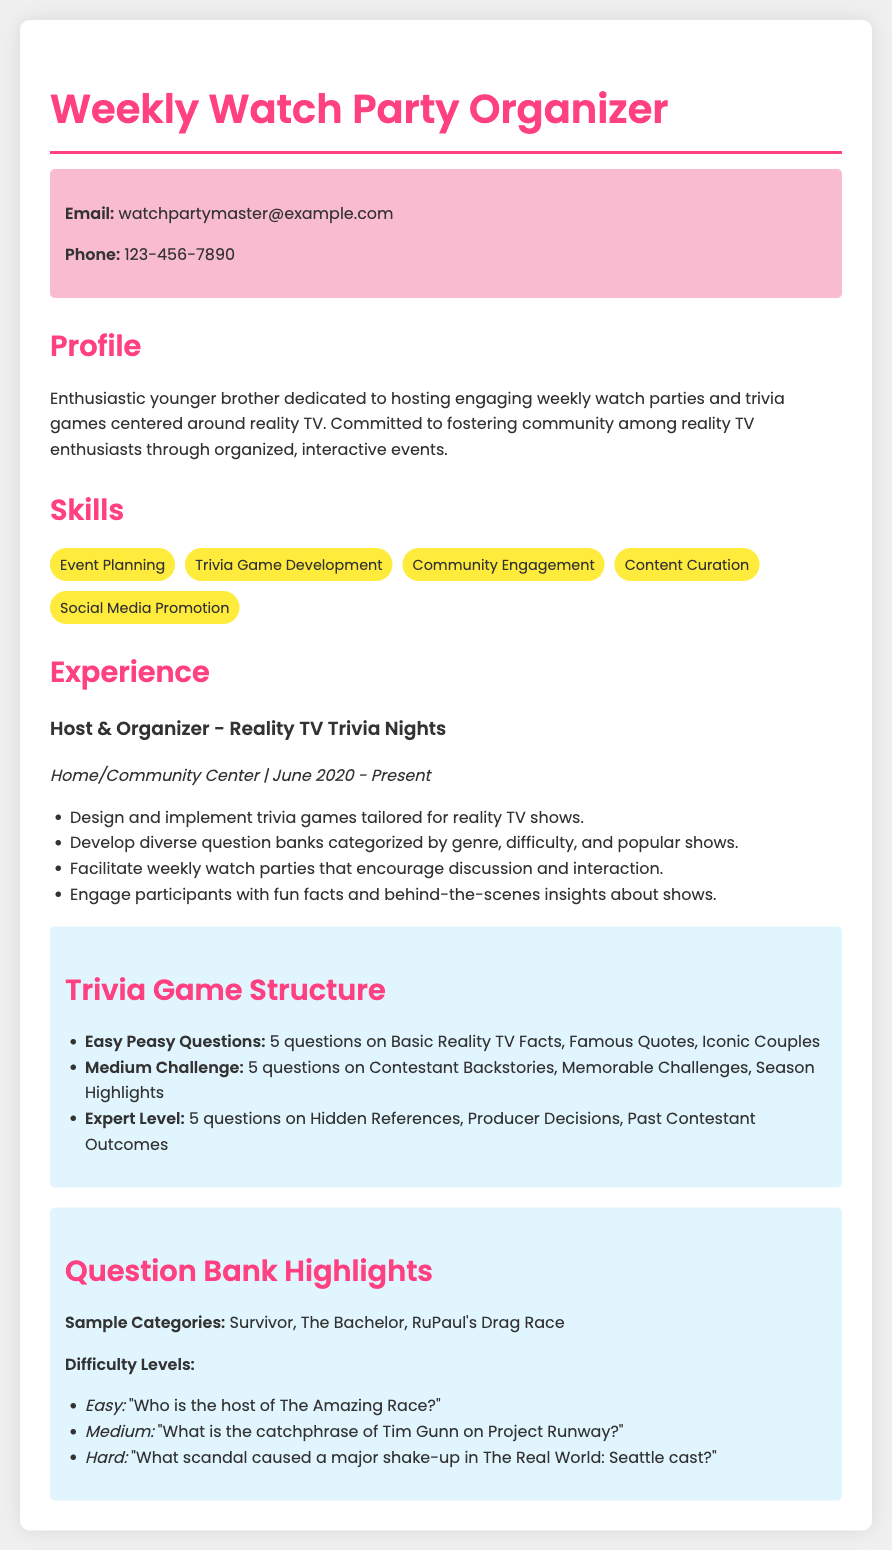what is the email address provided? The email address is listed in the contact-info section of the document.
Answer: watchpartymaster@example.com how many questions are in the Easy Peasy section? The document specifies that there are 5 questions in the Easy Peasy section of the trivia game structure.
Answer: 5 which reality TV shows are mentioned in the sample categories? The sample categories in the question bank highlights show the reality TV shows included.
Answer: Survivor, The Bachelor, RuPaul's Drag Race what is the duration of the experience listed in the CV? The experience duration provided is from June 2020 to Present, as mentioned in the experience section.
Answer: June 2020 - Present what is the main activity of the weekly watch parties? The purpose of the weekly watch parties is described in the profile section of the document.
Answer: Fostering community what is one of the skills listed in the skills section? The skills section lists several skills relevant to the role, confirming the expertise of the individual.
Answer: Trivia Game Development what type of trivia questions are asked under the Medium Challenge? The Easy, Medium, and Expert levels include different types of trivia questions, with Medium Challenge specifying a particular focus.
Answer: Contestant Backstories what is an example of an easy difficulty question? The question bank highlights provide a specific example of an easy question.
Answer: "Who is the host of The Amazing Race?" how many items are in the skills list? The skills section consists of several individual skills, which can be counted from the list provided.
Answer: 5 